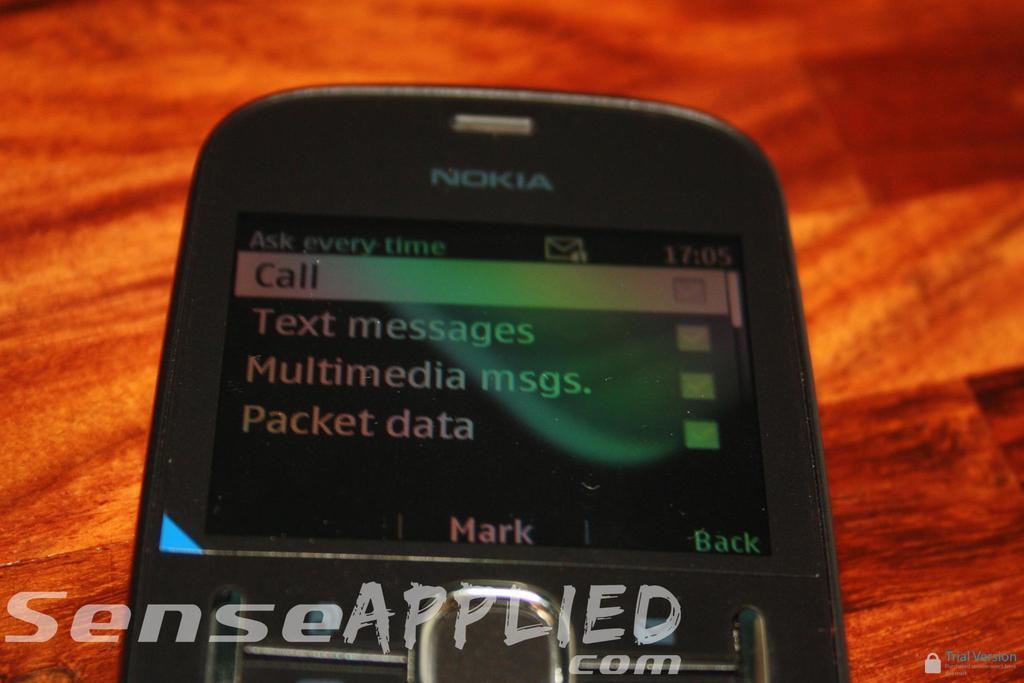What is the brand name of this phone?
Ensure brevity in your answer.  Nokia. What is the top option on the display?
Make the answer very short. Call. 